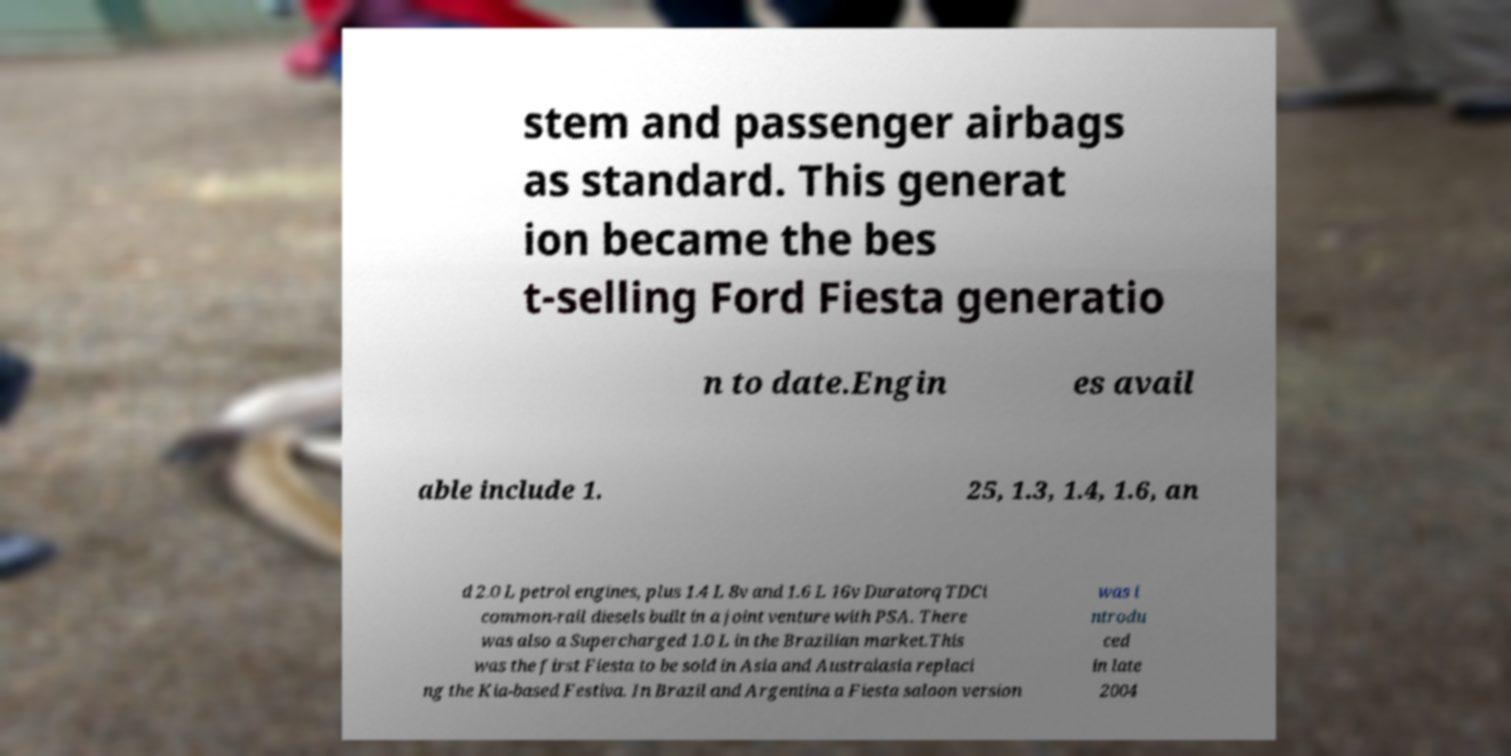Could you extract and type out the text from this image? stem and passenger airbags as standard. This generat ion became the bes t-selling Ford Fiesta generatio n to date.Engin es avail able include 1. 25, 1.3, 1.4, 1.6, an d 2.0 L petrol engines, plus 1.4 L 8v and 1.6 L 16v Duratorq TDCi common-rail diesels built in a joint venture with PSA. There was also a Supercharged 1.0 L in the Brazilian market.This was the first Fiesta to be sold in Asia and Australasia replaci ng the Kia-based Festiva. In Brazil and Argentina a Fiesta saloon version was i ntrodu ced in late 2004 